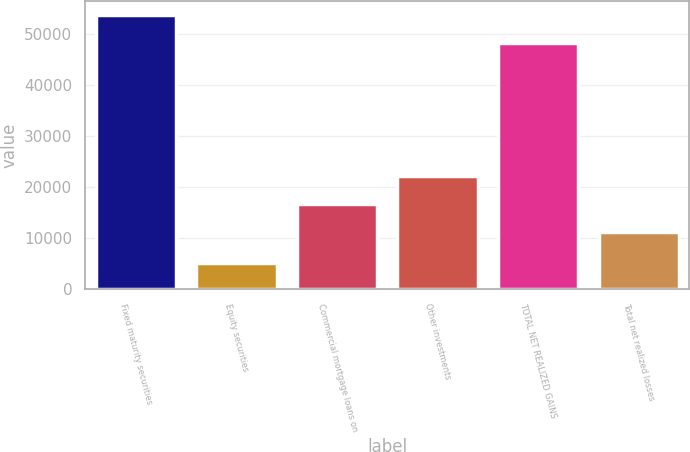Convert chart. <chart><loc_0><loc_0><loc_500><loc_500><bar_chart><fcel>Fixed maturity securities<fcel>Equity securities<fcel>Commercial mortgage loans on<fcel>Other investments<fcel>TOTAL NET REALIZED GAINS<fcel>Total net realized losses<nl><fcel>53880<fcel>5207<fcel>16710<fcel>22146.3<fcel>48403<fcel>11167<nl></chart> 